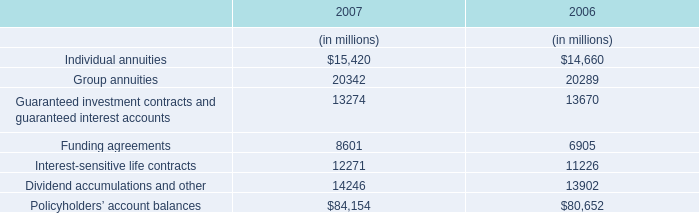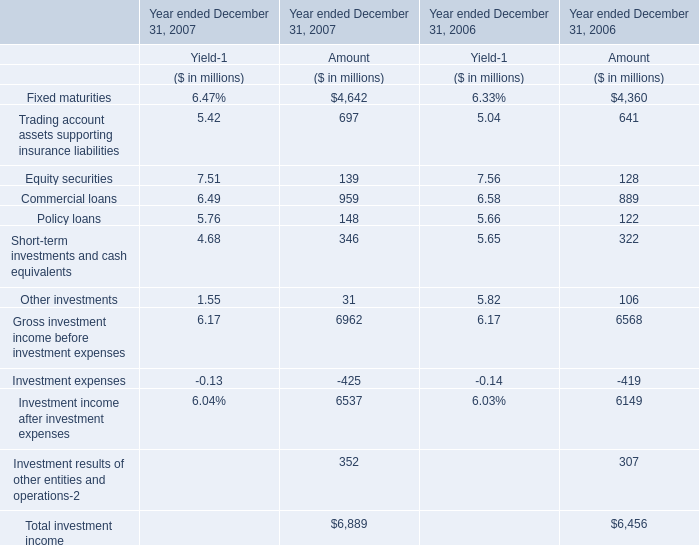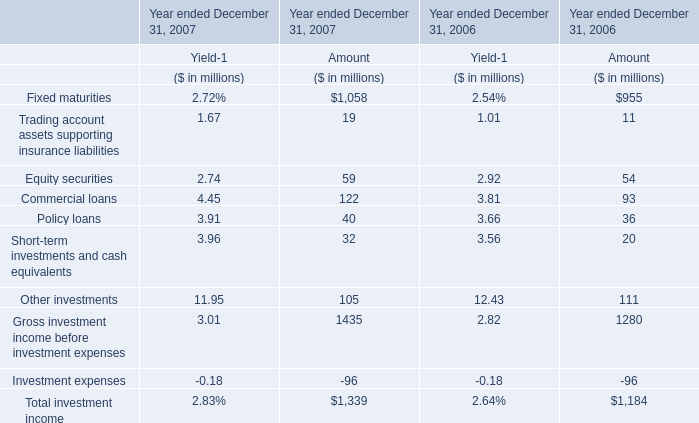In which year is Fixed maturities greater than 1 for amount? 
Answer: Year ended December 31, 2007 Year ended December 31, 2006. 